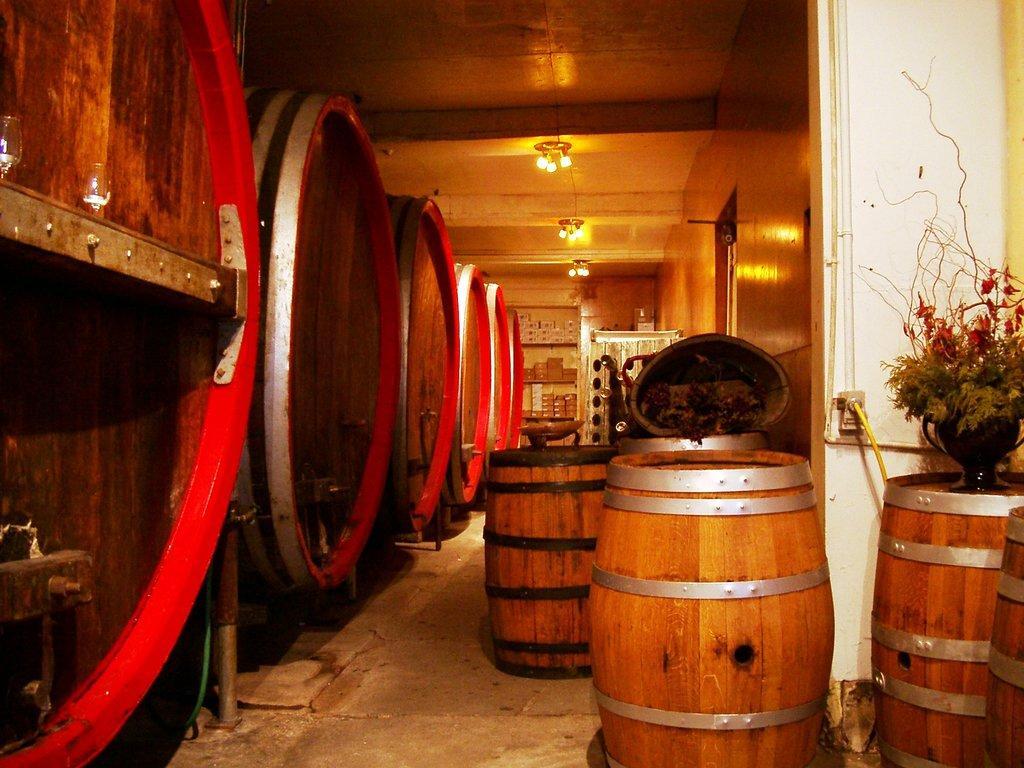How would you summarize this image in a sentence or two? In this picture I can see few barrels and I can see a plant on the barrel and few lights on the ceiling. 